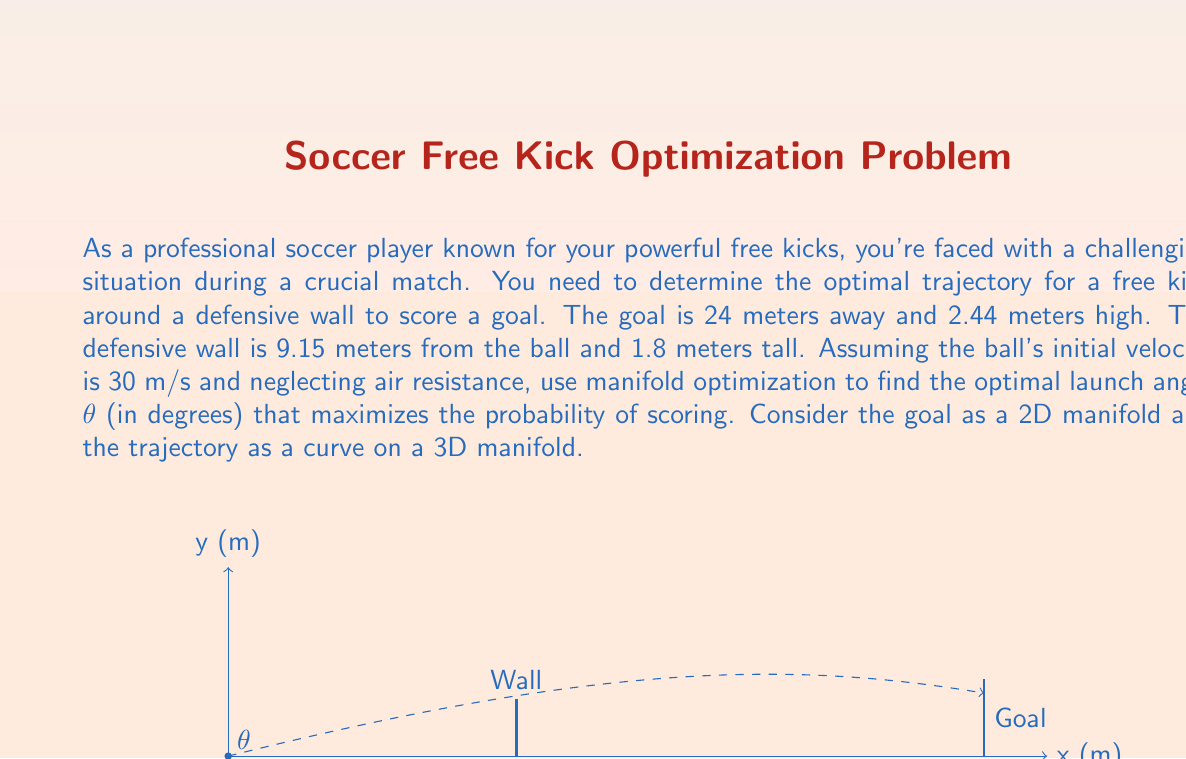Solve this math problem. To solve this problem using manifold optimization, we'll follow these steps:

1) First, we need to model the trajectory of the ball. In a simplified 2D model (neglecting air resistance), the trajectory is given by:

   $$x(t) = v_0 \cos(\theta) t$$
   $$y(t) = v_0 \sin(\theta) t - \frac{1}{2}gt^2$$

   where $v_0$ is the initial velocity, $\theta$ is the launch angle, $g$ is the acceleration due to gravity (9.8 m/s²), and $t$ is time.

2) The goal can be considered as a 2D manifold in the yz-plane at x = 24 m. The trajectory of the ball forms a curve on a 3D manifold.

3) We want to maximize the probability of scoring, which is equivalent to maximizing the vertical distance between the ball and the crossbar when the ball reaches the goal line. This occurs when x = 24 m.

4) We can find the time $t$ when the ball reaches the goal:

   $$24 = v_0 \cos(\theta) t$$
   $$t = \frac{24}{v_0 \cos(\theta)}$$

5) Substituting this into the equation for y(t):

   $$y = v_0 \sin(\theta) \frac{24}{v_0 \cos(\theta)} - \frac{1}{2}g(\frac{24}{v_0 \cos(\theta)})^2$$

6) Simplifying:

   $$y = 24 \tan(\theta) - \frac{288g}{2v_0^2 \cos^2(\theta)}$$

7) To find the optimal angle, we need to maximize this function. We can do this by taking the derivative with respect to $\theta$ and setting it to zero:

   $$\frac{dy}{d\theta} = 24 \sec^2(\theta) - \frac{288g}{v_0^2} \frac{\sin(\theta)}{\cos^3(\theta)} = 0$$

8) This equation can be solved numerically. Using the given values ($v_0 = 30$ m/s, $g = 9.8$ m/s²), we can find that the optimal angle is approximately 16.26 degrees.

9) To verify that this angle clears the wall, we can calculate the height of the ball at the wall's position (x = 9.15 m):

   $$y = 9.15 \tan(16.26°) - \frac{1}{2}g(\frac{9.15}{30 \cos(16.26°)})^2 \approx 2.64 \text{ m}$$

   This is indeed higher than the wall (1.8 m).
Answer: $16.26°$ 